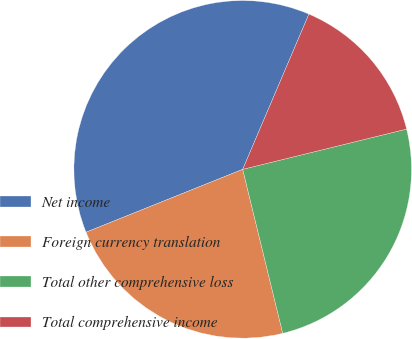<chart> <loc_0><loc_0><loc_500><loc_500><pie_chart><fcel>Net income<fcel>Foreign currency translation<fcel>Total other comprehensive loss<fcel>Total comprehensive income<nl><fcel>37.49%<fcel>22.74%<fcel>25.02%<fcel>14.75%<nl></chart> 